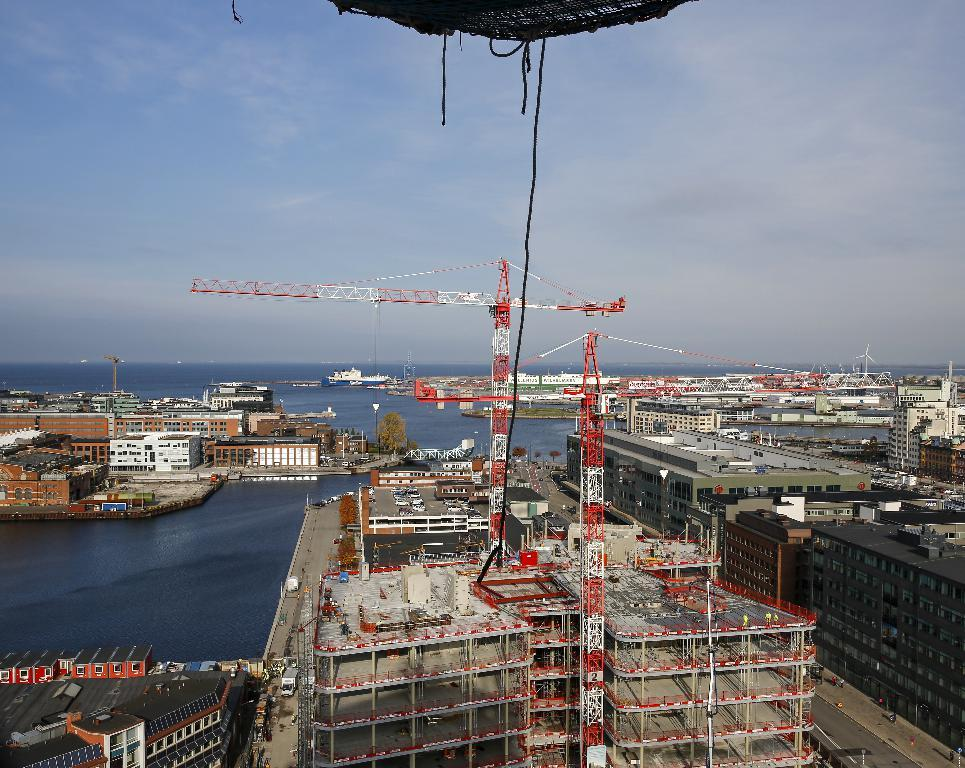What is the main feature of the image? The main feature of the image is water visible between buildings. What can be seen in the middle of the image? There are cranes in the middle of the image. What is visible in the background of the image? The sky is visible in the background of the image. What type of bun is being used to soak up the water in the image? There is no bun present in the image, and therefore no such activity can be observed. 